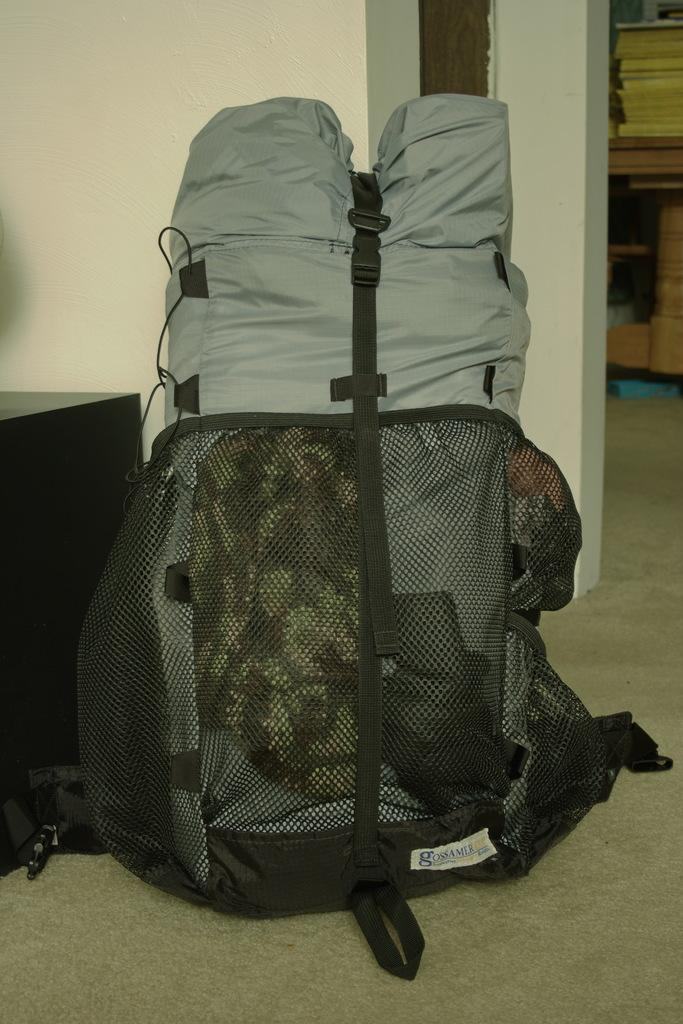Where was the image taken? The image was taken in a room. What is the main object in the center of the image? There is a backpack in the center of the image. What can be seen in the background of the image? There is a door and a table in the background of the image. How many glue sticks are on the table in the image? There is no mention of glue sticks or any glue-related items in the image. 